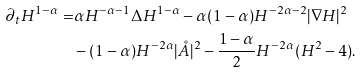<formula> <loc_0><loc_0><loc_500><loc_500>\partial _ { t } H ^ { 1 - \alpha } = & \alpha H ^ { - \alpha - 1 } \Delta H ^ { 1 - \alpha } - \alpha ( 1 - \alpha ) H ^ { - 2 \alpha - 2 } | \nabla H | ^ { 2 } \\ & - ( 1 - \alpha ) H ^ { - 2 \alpha } | \mathring { A } | ^ { 2 } - \frac { 1 - \alpha } 2 H ^ { - 2 \alpha } ( H ^ { 2 } - 4 ) .</formula> 